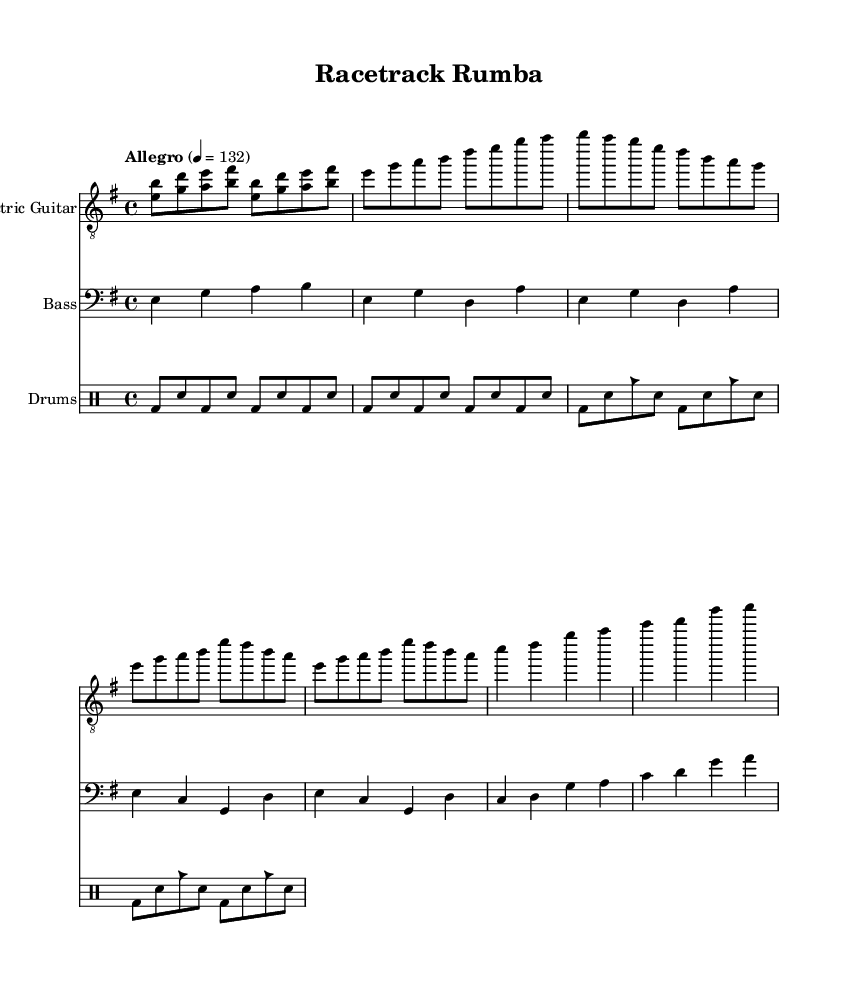What is the key signature of this music? The key signature is indicated at the beginning of the score, where the sharp or flat symbols are found. In this case, the score shows one sharp on the F line, which identifies it as E minor (or G major).
Answer: E minor What is the time signature of this music? The time signature is located at the beginning of the score, written as a fraction. It displays "4/4", meaning there are 4 beats in each measure.
Answer: 4/4 What is the tempo marking for this piece? The tempo marking appears above the music staff and indicates the speed. It states "Allegro" at a quarter note equals 132 beats per minute.
Answer: Allegro, 132 How many measures are in the Chorus section? To determine the number of measures, I look at the Chorus part and count each grouping between vertical lines, with each line representing a measure. The Chorus consists of two repeated sections, each with four measures, making a total of eight measures.
Answer: 8 What rhythmic element is added in the drums to provide a Latin feel? The Latin character is introduced through the presence of cowbell (cb). This element is used in the drum pattern, reflecting the Latin influence on the piece.
Answer: Cowbell What unique feature indicates that this piece is a fusion of Latin rock and other styles? The structure combines traditional rock elements, like the straight rock beat, with Latin rhythms and instrumentation, evidenced by the distinctive patterns and the addition of cowbell in the drum section.
Answer: Latin rhythms and instrumentation 